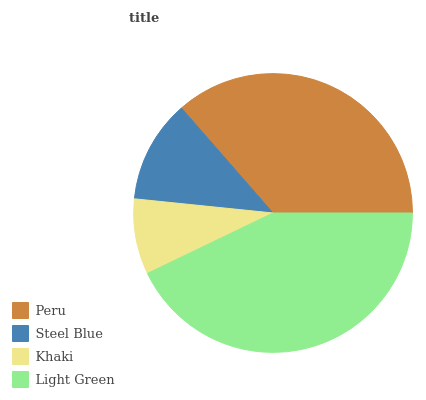Is Khaki the minimum?
Answer yes or no. Yes. Is Light Green the maximum?
Answer yes or no. Yes. Is Steel Blue the minimum?
Answer yes or no. No. Is Steel Blue the maximum?
Answer yes or no. No. Is Peru greater than Steel Blue?
Answer yes or no. Yes. Is Steel Blue less than Peru?
Answer yes or no. Yes. Is Steel Blue greater than Peru?
Answer yes or no. No. Is Peru less than Steel Blue?
Answer yes or no. No. Is Peru the high median?
Answer yes or no. Yes. Is Steel Blue the low median?
Answer yes or no. Yes. Is Light Green the high median?
Answer yes or no. No. Is Light Green the low median?
Answer yes or no. No. 